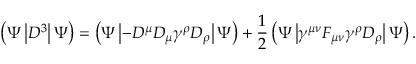Convert formula to latex. <formula><loc_0><loc_0><loc_500><loc_500>\left ( \Psi \left | D ^ { 3 } \right | \Psi \right ) = \left ( \Psi \left | - D ^ { \mu } D _ { \mu } \gamma ^ { \rho } D _ { \rho } \right | \Psi \right ) + \frac { 1 } { 2 } \left ( \Psi \left | \gamma ^ { \mu \nu } F _ { \mu \nu } \gamma ^ { \rho } D _ { \rho } \right | \Psi \right ) .</formula> 